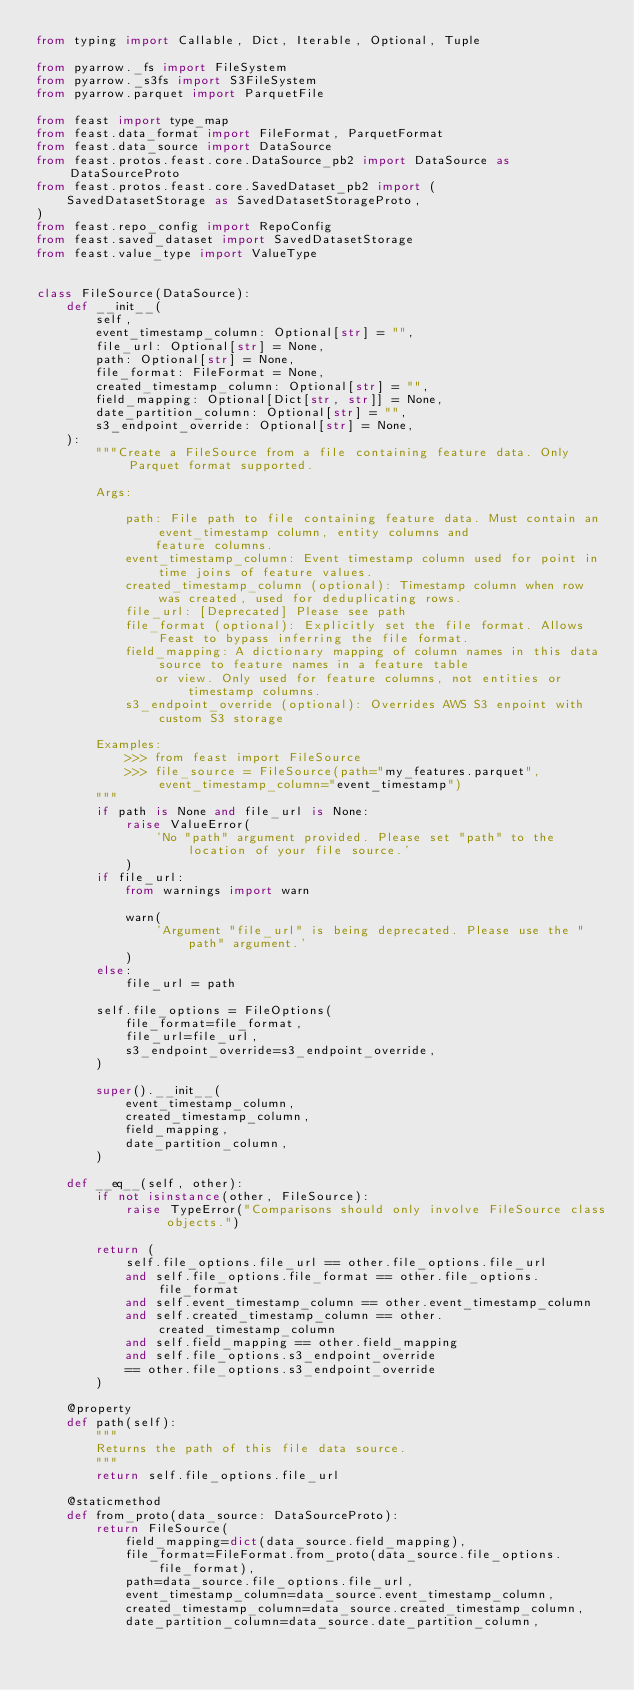<code> <loc_0><loc_0><loc_500><loc_500><_Python_>from typing import Callable, Dict, Iterable, Optional, Tuple

from pyarrow._fs import FileSystem
from pyarrow._s3fs import S3FileSystem
from pyarrow.parquet import ParquetFile

from feast import type_map
from feast.data_format import FileFormat, ParquetFormat
from feast.data_source import DataSource
from feast.protos.feast.core.DataSource_pb2 import DataSource as DataSourceProto
from feast.protos.feast.core.SavedDataset_pb2 import (
    SavedDatasetStorage as SavedDatasetStorageProto,
)
from feast.repo_config import RepoConfig
from feast.saved_dataset import SavedDatasetStorage
from feast.value_type import ValueType


class FileSource(DataSource):
    def __init__(
        self,
        event_timestamp_column: Optional[str] = "",
        file_url: Optional[str] = None,
        path: Optional[str] = None,
        file_format: FileFormat = None,
        created_timestamp_column: Optional[str] = "",
        field_mapping: Optional[Dict[str, str]] = None,
        date_partition_column: Optional[str] = "",
        s3_endpoint_override: Optional[str] = None,
    ):
        """Create a FileSource from a file containing feature data. Only Parquet format supported.

        Args:

            path: File path to file containing feature data. Must contain an event_timestamp column, entity columns and
                feature columns.
            event_timestamp_column: Event timestamp column used for point in time joins of feature values.
            created_timestamp_column (optional): Timestamp column when row was created, used for deduplicating rows.
            file_url: [Deprecated] Please see path
            file_format (optional): Explicitly set the file format. Allows Feast to bypass inferring the file format.
            field_mapping: A dictionary mapping of column names in this data source to feature names in a feature table
                or view. Only used for feature columns, not entities or timestamp columns.
            s3_endpoint_override (optional): Overrides AWS S3 enpoint with custom S3 storage

        Examples:
            >>> from feast import FileSource
            >>> file_source = FileSource(path="my_features.parquet", event_timestamp_column="event_timestamp")
        """
        if path is None and file_url is None:
            raise ValueError(
                'No "path" argument provided. Please set "path" to the location of your file source.'
            )
        if file_url:
            from warnings import warn

            warn(
                'Argument "file_url" is being deprecated. Please use the "path" argument.'
            )
        else:
            file_url = path

        self.file_options = FileOptions(
            file_format=file_format,
            file_url=file_url,
            s3_endpoint_override=s3_endpoint_override,
        )

        super().__init__(
            event_timestamp_column,
            created_timestamp_column,
            field_mapping,
            date_partition_column,
        )

    def __eq__(self, other):
        if not isinstance(other, FileSource):
            raise TypeError("Comparisons should only involve FileSource class objects.")

        return (
            self.file_options.file_url == other.file_options.file_url
            and self.file_options.file_format == other.file_options.file_format
            and self.event_timestamp_column == other.event_timestamp_column
            and self.created_timestamp_column == other.created_timestamp_column
            and self.field_mapping == other.field_mapping
            and self.file_options.s3_endpoint_override
            == other.file_options.s3_endpoint_override
        )

    @property
    def path(self):
        """
        Returns the path of this file data source.
        """
        return self.file_options.file_url

    @staticmethod
    def from_proto(data_source: DataSourceProto):
        return FileSource(
            field_mapping=dict(data_source.field_mapping),
            file_format=FileFormat.from_proto(data_source.file_options.file_format),
            path=data_source.file_options.file_url,
            event_timestamp_column=data_source.event_timestamp_column,
            created_timestamp_column=data_source.created_timestamp_column,
            date_partition_column=data_source.date_partition_column,</code> 